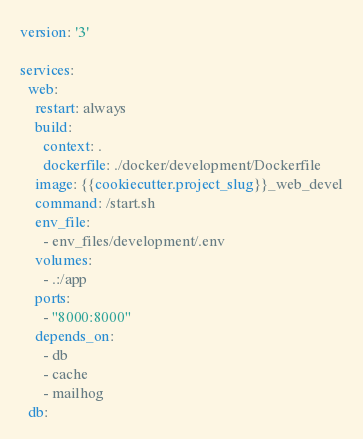<code> <loc_0><loc_0><loc_500><loc_500><_YAML_>version: '3'

services:
  web:
    restart: always
    build:
      context: .
      dockerfile: ./docker/development/Dockerfile
    image: {{cookiecutter.project_slug}}_web_devel
    command: /start.sh
    env_file:
      - env_files/development/.env
    volumes:
      - .:/app
    ports:
      - "8000:8000"
    depends_on:
      - db
      - cache
      - mailhog
  db:</code> 